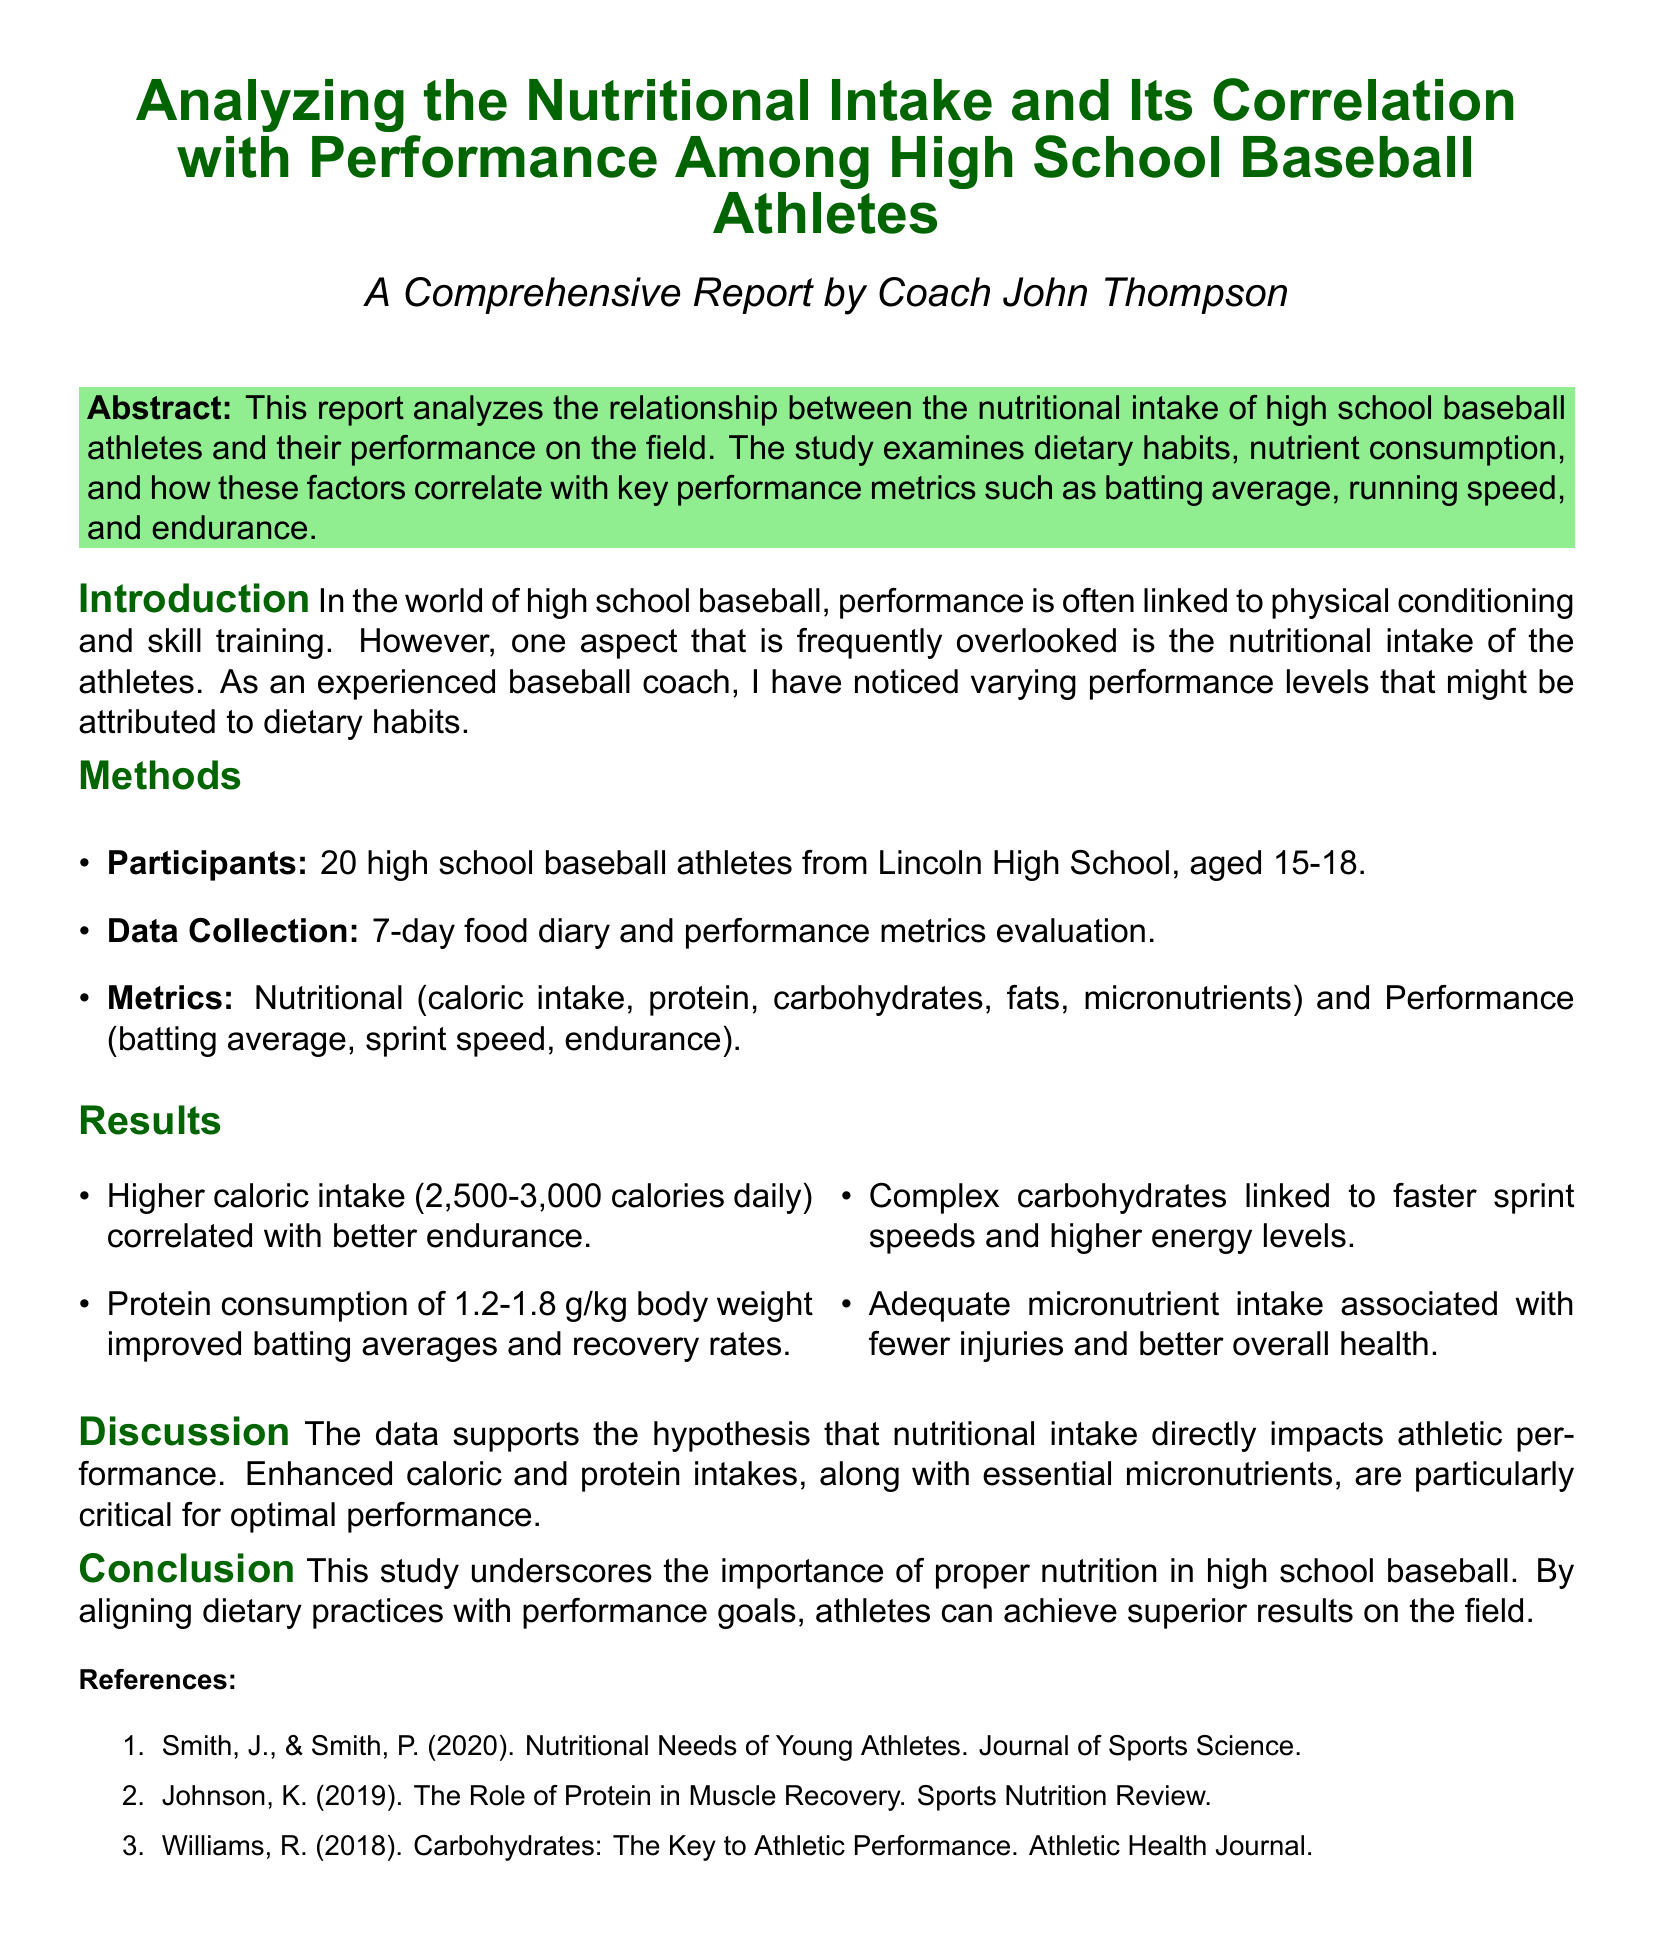What is the title of the report? The title provides the main subject of the document and is stated in the introduction section.
Answer: Analyzing the Nutritional Intake and Its Correlation with Performance Among High School Baseball Athletes How many participants were involved in the study? This information is found under the Methods section where participant details are outlined.
Answer: 20 What age range do the participants fall under? The age range of participants is mentioned in the Methods section, providing specifics about their ages.
Answer: 15-18 What is the range of daily caloric intake associated with better endurance? The Results section contains details about the correlation between caloric intake and endurance, specifying a range.
Answer: 2,500-3,000 calories What nutrient intake improved batting averages? The Results mention the specific nutrient that is linked to improved batting averages, focusing on protein consumption.
Answer: Protein What type of carbohydrates is linked to faster sprint speeds? The Results discuss the correlation between carbohydrate types and athletic performance, specifically sprint speeds.
Answer: Complex carbohydrates Which section discusses the implications of nutritional intake on athletic performance? The Discussion section reflects on the findings from the study, connecting dietary habits with athletic performance outcomes.
Answer: Discussion What is the conclusion of the study regarding nutrition? The Conclusion succinctly summarizes the main findings about the importance of nutrition for high school baseball athletes.
Answer: Importance of proper nutrition 